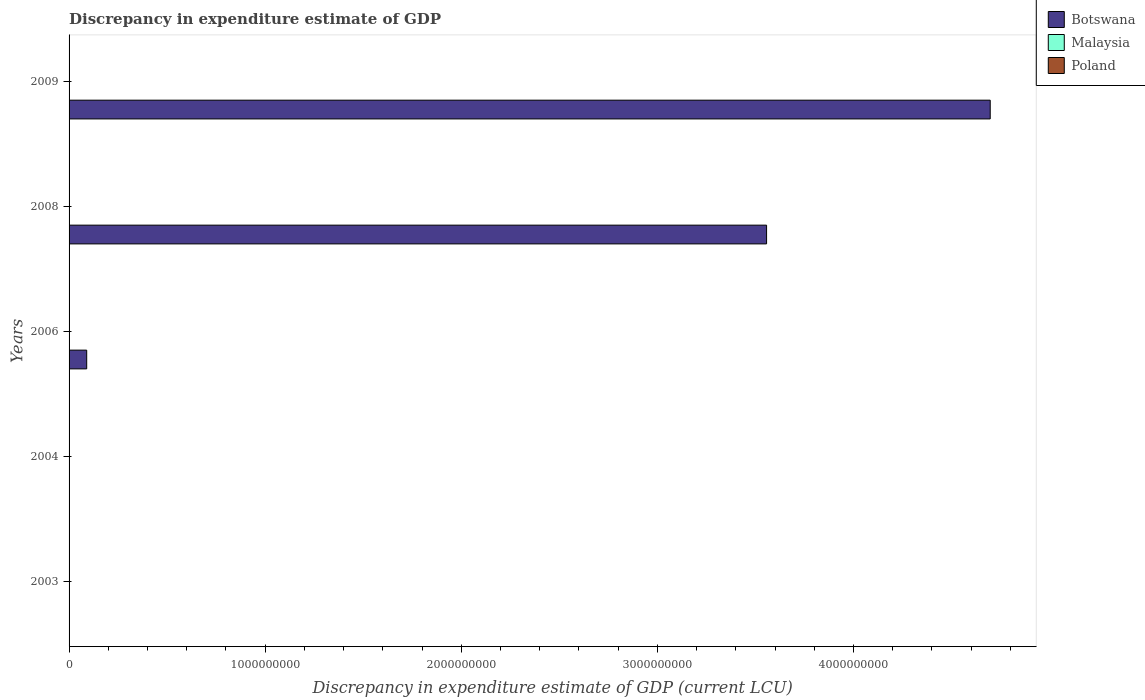How many different coloured bars are there?
Provide a succinct answer. 3. How many bars are there on the 2nd tick from the top?
Provide a succinct answer. 1. How many bars are there on the 1st tick from the bottom?
Your response must be concise. 2. What is the label of the 1st group of bars from the top?
Provide a succinct answer. 2009. What is the discrepancy in expenditure estimate of GDP in Botswana in 2008?
Make the answer very short. 3.56e+09. Across all years, what is the maximum discrepancy in expenditure estimate of GDP in Botswana?
Your answer should be very brief. 4.70e+09. Across all years, what is the minimum discrepancy in expenditure estimate of GDP in Malaysia?
Provide a succinct answer. 0. In which year was the discrepancy in expenditure estimate of GDP in Malaysia maximum?
Keep it short and to the point. 2004. What is the total discrepancy in expenditure estimate of GDP in Malaysia in the graph?
Ensure brevity in your answer.  3.00e+06. What is the difference between the discrepancy in expenditure estimate of GDP in Botswana in 2006 and that in 2009?
Offer a terse response. -4.61e+09. What is the difference between the discrepancy in expenditure estimate of GDP in Poland in 2004 and the discrepancy in expenditure estimate of GDP in Botswana in 2006?
Provide a short and direct response. -8.99e+07. What is the average discrepancy in expenditure estimate of GDP in Botswana per year?
Offer a terse response. 1.67e+09. In how many years, is the discrepancy in expenditure estimate of GDP in Botswana greater than 3600000000 LCU?
Your answer should be very brief. 1. What is the difference between the highest and the second highest discrepancy in expenditure estimate of GDP in Botswana?
Give a very brief answer. 1.14e+09. What is the difference between the highest and the lowest discrepancy in expenditure estimate of GDP in Poland?
Offer a very short reply. 0. How many legend labels are there?
Provide a succinct answer. 3. How are the legend labels stacked?
Give a very brief answer. Vertical. What is the title of the graph?
Provide a succinct answer. Discrepancy in expenditure estimate of GDP. Does "Antigua and Barbuda" appear as one of the legend labels in the graph?
Offer a very short reply. No. What is the label or title of the X-axis?
Keep it short and to the point. Discrepancy in expenditure estimate of GDP (current LCU). What is the Discrepancy in expenditure estimate of GDP (current LCU) in Botswana in 2003?
Make the answer very short. 0. What is the Discrepancy in expenditure estimate of GDP (current LCU) in Malaysia in 2003?
Keep it short and to the point. 1.00e+06. What is the Discrepancy in expenditure estimate of GDP (current LCU) of Poland in 2003?
Your answer should be compact. 0. What is the Discrepancy in expenditure estimate of GDP (current LCU) of Malaysia in 2004?
Your answer should be very brief. 2.00e+06. What is the Discrepancy in expenditure estimate of GDP (current LCU) in Poland in 2004?
Keep it short and to the point. 6e-5. What is the Discrepancy in expenditure estimate of GDP (current LCU) of Botswana in 2006?
Make the answer very short. 8.99e+07. What is the Discrepancy in expenditure estimate of GDP (current LCU) in Poland in 2006?
Your answer should be compact. 0. What is the Discrepancy in expenditure estimate of GDP (current LCU) of Botswana in 2008?
Offer a terse response. 3.56e+09. What is the Discrepancy in expenditure estimate of GDP (current LCU) in Malaysia in 2008?
Offer a terse response. 0. What is the Discrepancy in expenditure estimate of GDP (current LCU) of Poland in 2008?
Your answer should be very brief. 0. What is the Discrepancy in expenditure estimate of GDP (current LCU) in Botswana in 2009?
Provide a short and direct response. 4.70e+09. Across all years, what is the maximum Discrepancy in expenditure estimate of GDP (current LCU) of Botswana?
Keep it short and to the point. 4.70e+09. Across all years, what is the maximum Discrepancy in expenditure estimate of GDP (current LCU) of Malaysia?
Keep it short and to the point. 2.00e+06. Across all years, what is the maximum Discrepancy in expenditure estimate of GDP (current LCU) of Poland?
Your answer should be compact. 0. Across all years, what is the minimum Discrepancy in expenditure estimate of GDP (current LCU) of Botswana?
Offer a very short reply. 0. Across all years, what is the minimum Discrepancy in expenditure estimate of GDP (current LCU) of Malaysia?
Ensure brevity in your answer.  0. What is the total Discrepancy in expenditure estimate of GDP (current LCU) of Botswana in the graph?
Provide a short and direct response. 8.34e+09. What is the difference between the Discrepancy in expenditure estimate of GDP (current LCU) in Malaysia in 2003 and that in 2004?
Your answer should be very brief. -1.00e+06. What is the difference between the Discrepancy in expenditure estimate of GDP (current LCU) of Botswana in 2006 and that in 2008?
Provide a short and direct response. -3.47e+09. What is the difference between the Discrepancy in expenditure estimate of GDP (current LCU) in Botswana in 2006 and that in 2009?
Your response must be concise. -4.61e+09. What is the difference between the Discrepancy in expenditure estimate of GDP (current LCU) in Botswana in 2008 and that in 2009?
Provide a succinct answer. -1.14e+09. What is the difference between the Discrepancy in expenditure estimate of GDP (current LCU) in Malaysia in 2003 and the Discrepancy in expenditure estimate of GDP (current LCU) in Poland in 2004?
Your answer should be very brief. 1.00e+06. What is the average Discrepancy in expenditure estimate of GDP (current LCU) of Botswana per year?
Your response must be concise. 1.67e+09. What is the average Discrepancy in expenditure estimate of GDP (current LCU) in Malaysia per year?
Offer a very short reply. 6.00e+05. In the year 2003, what is the difference between the Discrepancy in expenditure estimate of GDP (current LCU) in Malaysia and Discrepancy in expenditure estimate of GDP (current LCU) in Poland?
Give a very brief answer. 1.00e+06. In the year 2004, what is the difference between the Discrepancy in expenditure estimate of GDP (current LCU) in Malaysia and Discrepancy in expenditure estimate of GDP (current LCU) in Poland?
Your response must be concise. 2.00e+06. What is the ratio of the Discrepancy in expenditure estimate of GDP (current LCU) of Malaysia in 2003 to that in 2004?
Offer a terse response. 0.5. What is the ratio of the Discrepancy in expenditure estimate of GDP (current LCU) in Poland in 2003 to that in 2004?
Provide a succinct answer. 2. What is the ratio of the Discrepancy in expenditure estimate of GDP (current LCU) of Botswana in 2006 to that in 2008?
Offer a very short reply. 0.03. What is the ratio of the Discrepancy in expenditure estimate of GDP (current LCU) in Botswana in 2006 to that in 2009?
Your answer should be compact. 0.02. What is the ratio of the Discrepancy in expenditure estimate of GDP (current LCU) of Botswana in 2008 to that in 2009?
Your answer should be compact. 0.76. What is the difference between the highest and the second highest Discrepancy in expenditure estimate of GDP (current LCU) of Botswana?
Offer a terse response. 1.14e+09. What is the difference between the highest and the lowest Discrepancy in expenditure estimate of GDP (current LCU) of Botswana?
Provide a short and direct response. 4.70e+09. What is the difference between the highest and the lowest Discrepancy in expenditure estimate of GDP (current LCU) in Malaysia?
Provide a short and direct response. 2.00e+06. What is the difference between the highest and the lowest Discrepancy in expenditure estimate of GDP (current LCU) in Poland?
Provide a short and direct response. 0. 